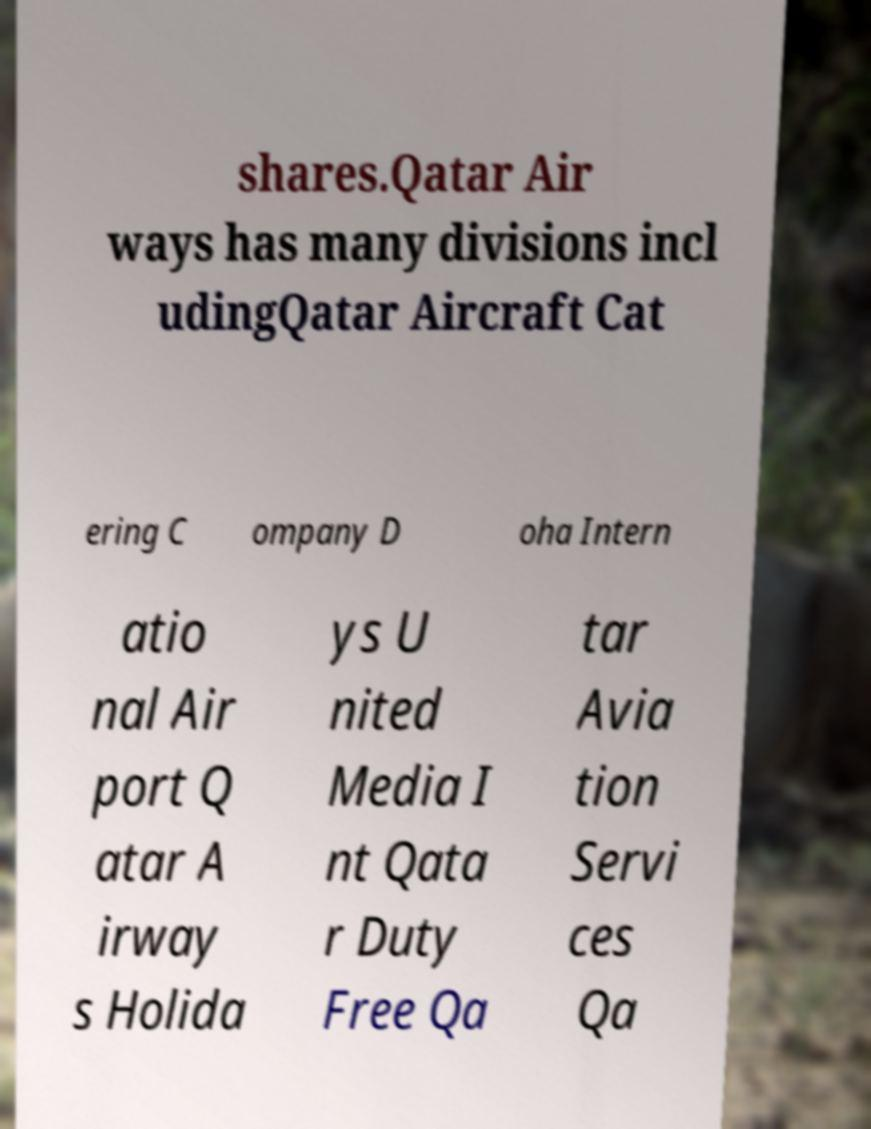Could you extract and type out the text from this image? shares.Qatar Air ways has many divisions incl udingQatar Aircraft Cat ering C ompany D oha Intern atio nal Air port Q atar A irway s Holida ys U nited Media I nt Qata r Duty Free Qa tar Avia tion Servi ces Qa 